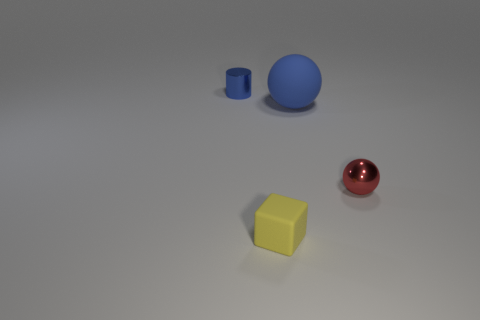Add 2 gray metallic spheres. How many objects exist? 6 Subtract all blue balls. How many balls are left? 1 Subtract 0 red cubes. How many objects are left? 4 Subtract all cylinders. How many objects are left? 3 Subtract 2 spheres. How many spheres are left? 0 Subtract all yellow balls. Subtract all green cubes. How many balls are left? 2 Subtract all large green balls. Subtract all rubber blocks. How many objects are left? 3 Add 2 red objects. How many red objects are left? 3 Add 3 small rubber things. How many small rubber things exist? 4 